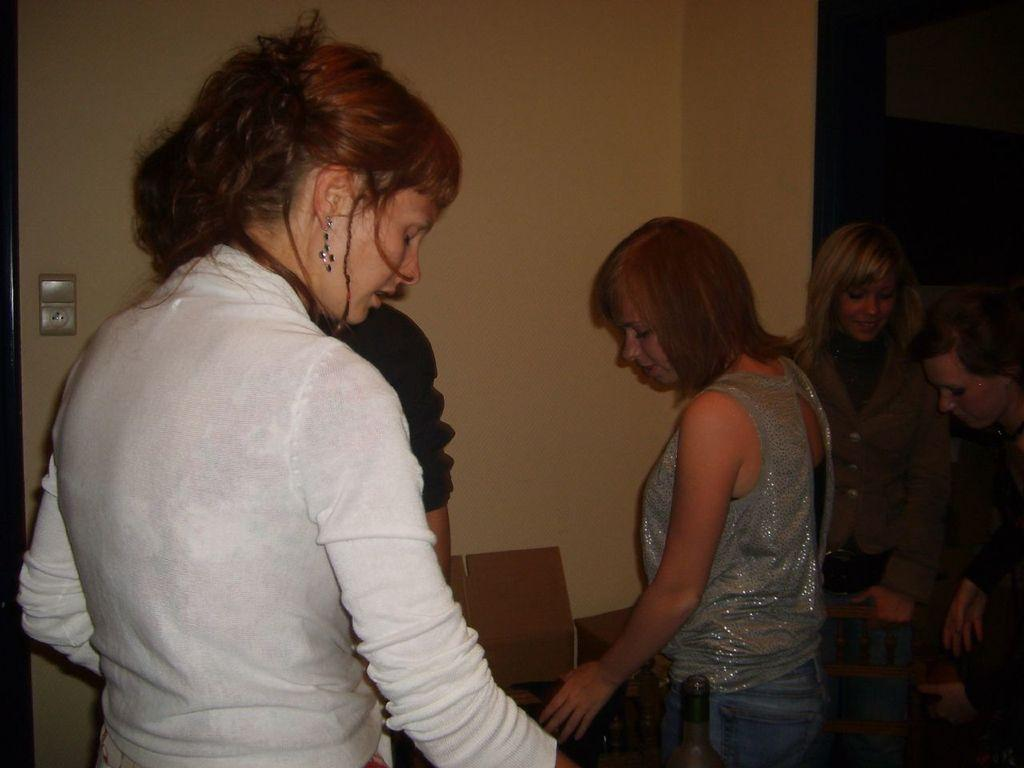How many people are in the image? There is a group of people in the image, but the exact number cannot be determined from the provided facts. What can be seen in the background of the image? There is a wall and a fan regulator visible in the background of the image. Are there any other objects visible in the background? Yes, there are other objects visible in the background of the image. What type of calculator is being used by the people in the image? There is no calculator present in the image. What is the aftermath of the match in the image? There is no match or any indication of a match in the image. 